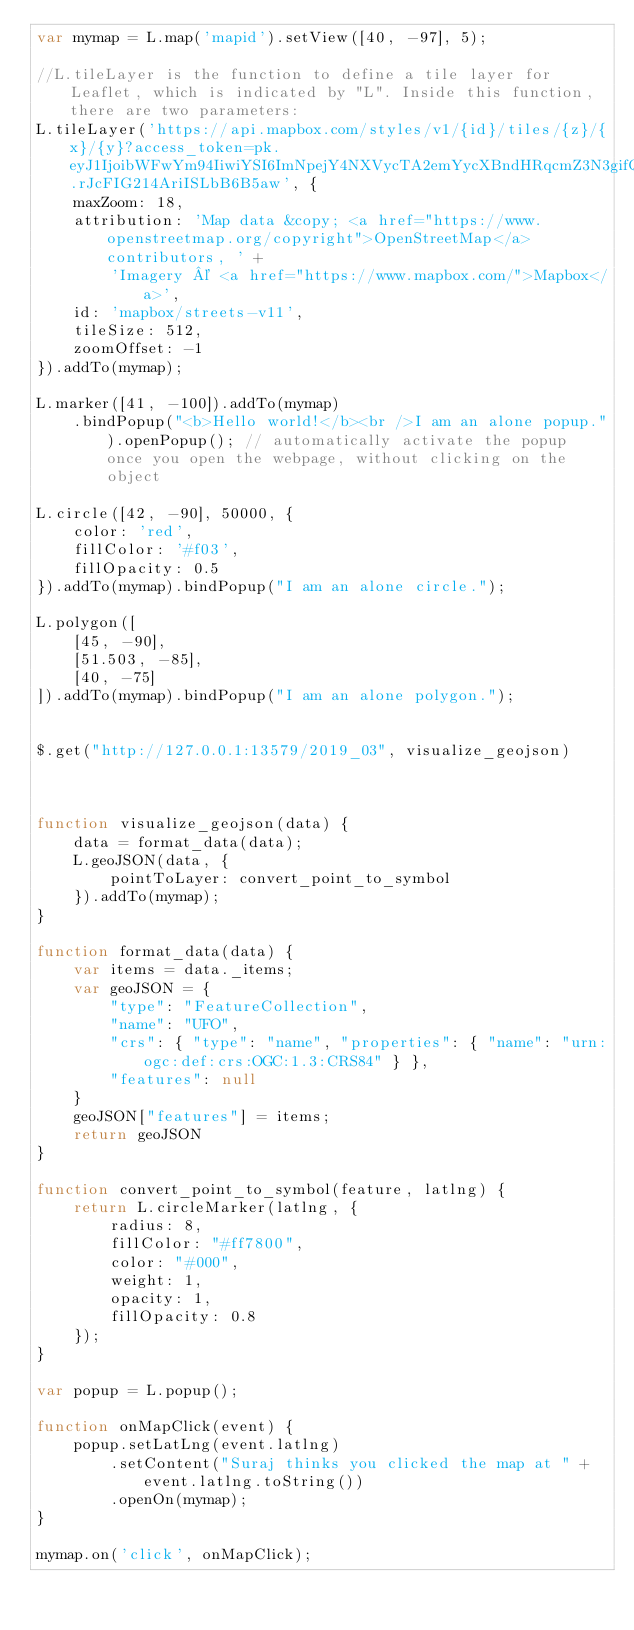Convert code to text. <code><loc_0><loc_0><loc_500><loc_500><_JavaScript_>var mymap = L.map('mapid').setView([40, -97], 5);

//L.tileLayer is the function to define a tile layer for Leaflet, which is indicated by "L". Inside this function, there are two parameters:
L.tileLayer('https://api.mapbox.com/styles/v1/{id}/tiles/{z}/{x}/{y}?access_token=pk.eyJ1IjoibWFwYm94IiwiYSI6ImNpejY4NXVycTA2emYycXBndHRqcmZ3N3gifQ.rJcFIG214AriISLbB6B5aw', {
    maxZoom: 18,
    attribution: 'Map data &copy; <a href="https://www.openstreetmap.org/copyright">OpenStreetMap</a> contributors, ' +
        'Imagery © <a href="https://www.mapbox.com/">Mapbox</a>',
    id: 'mapbox/streets-v11',
    tileSize: 512,
    zoomOffset: -1
}).addTo(mymap);

L.marker([41, -100]).addTo(mymap)
    .bindPopup("<b>Hello world!</b><br />I am an alone popup.").openPopup(); // automatically activate the popup once you open the webpage, without clicking on the object

L.circle([42, -90], 50000, {
    color: 'red',
    fillColor: '#f03',
    fillOpacity: 0.5
}).addTo(mymap).bindPopup("I am an alone circle.");

L.polygon([
    [45, -90],
    [51.503, -85],
    [40, -75]
]).addTo(mymap).bindPopup("I am an alone polygon.");


$.get("http://127.0.0.1:13579/2019_03", visualize_geojson)



function visualize_geojson(data) {
    data = format_data(data);
    L.geoJSON(data, {
        pointToLayer: convert_point_to_symbol
    }).addTo(mymap);
}

function format_data(data) {
    var items = data._items;
    var geoJSON = {
        "type": "FeatureCollection",
        "name": "UFO",
        "crs": { "type": "name", "properties": { "name": "urn:ogc:def:crs:OGC:1.3:CRS84" } },
        "features": null
    }
    geoJSON["features"] = items;
    return geoJSON
}

function convert_point_to_symbol(feature, latlng) {
    return L.circleMarker(latlng, {
        radius: 8,
        fillColor: "#ff7800",
        color: "#000",
        weight: 1,
        opacity: 1,
        fillOpacity: 0.8
    });
}

var popup = L.popup();

function onMapClick(event) {
    popup.setLatLng(event.latlng)
        .setContent("Suraj thinks you clicked the map at " + event.latlng.toString())
        .openOn(mymap);
}

mymap.on('click', onMapClick);</code> 